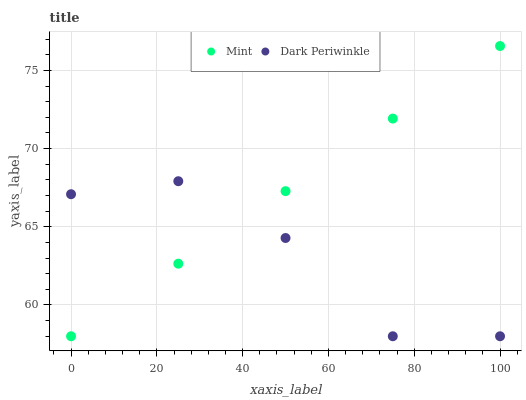Does Dark Periwinkle have the minimum area under the curve?
Answer yes or no. Yes. Does Mint have the maximum area under the curve?
Answer yes or no. Yes. Does Dark Periwinkle have the maximum area under the curve?
Answer yes or no. No. Is Mint the smoothest?
Answer yes or no. Yes. Is Dark Periwinkle the roughest?
Answer yes or no. Yes. Is Dark Periwinkle the smoothest?
Answer yes or no. No. Does Mint have the lowest value?
Answer yes or no. Yes. Does Mint have the highest value?
Answer yes or no. Yes. Does Dark Periwinkle have the highest value?
Answer yes or no. No. Does Dark Periwinkle intersect Mint?
Answer yes or no. Yes. Is Dark Periwinkle less than Mint?
Answer yes or no. No. Is Dark Periwinkle greater than Mint?
Answer yes or no. No. 